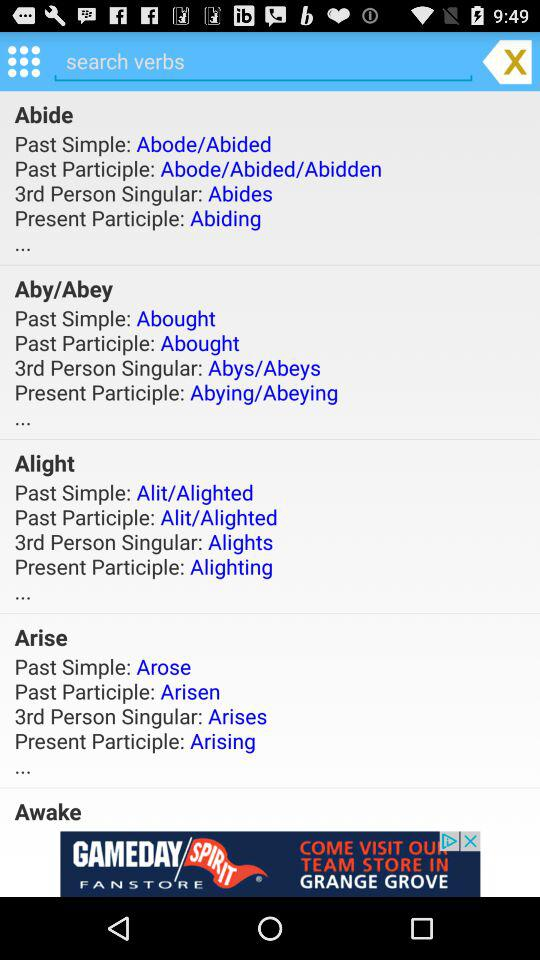What is the 3rd person singular of "Alight"? The 3rd person singular is "Alights". 